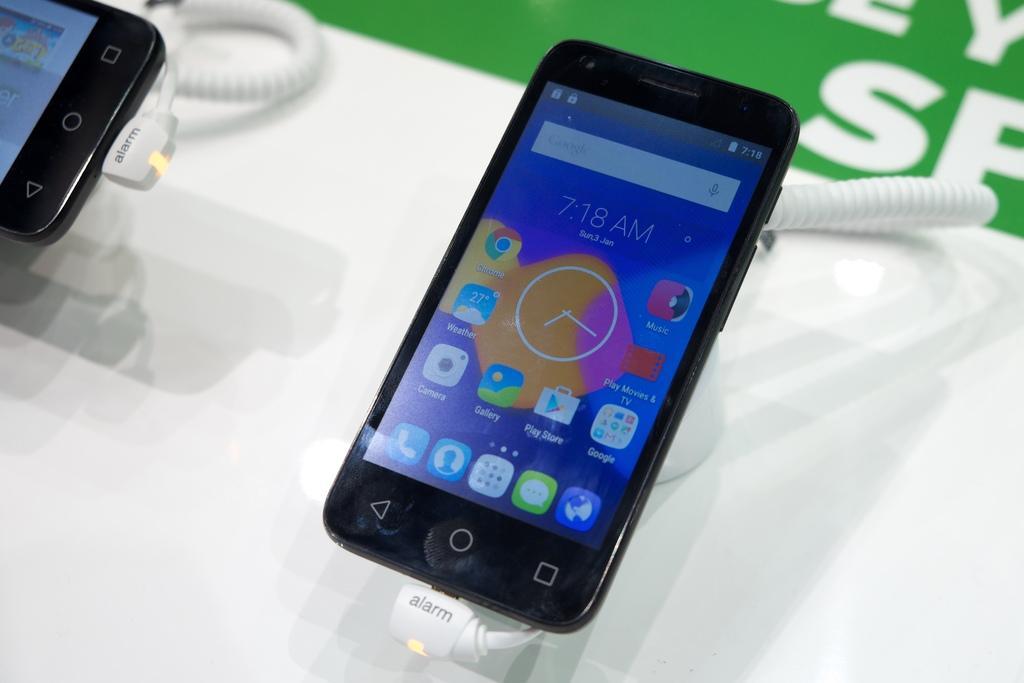How would you summarize this image in a sentence or two? Here in this picture we can see mobile phones connected with cable wires present over a place. 